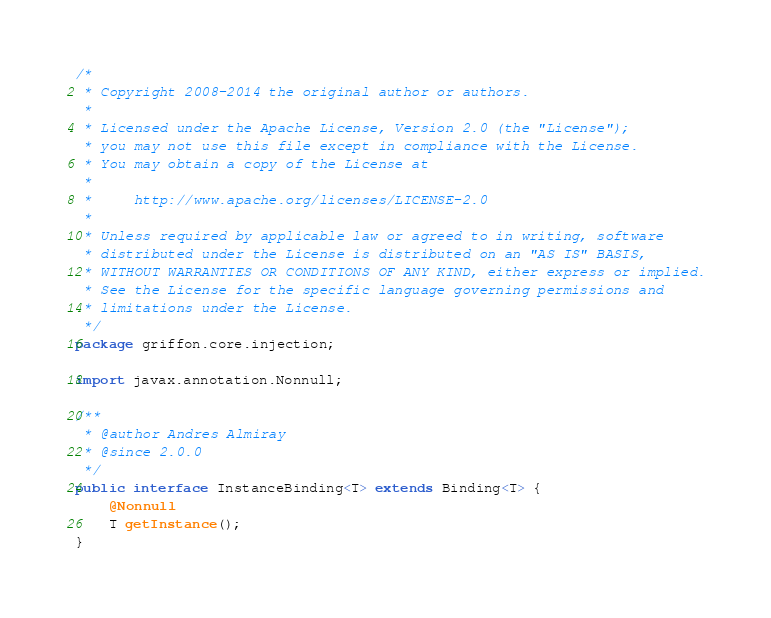Convert code to text. <code><loc_0><loc_0><loc_500><loc_500><_Java_>/*
 * Copyright 2008-2014 the original author or authors.
 *
 * Licensed under the Apache License, Version 2.0 (the "License");
 * you may not use this file except in compliance with the License.
 * You may obtain a copy of the License at
 *
 *     http://www.apache.org/licenses/LICENSE-2.0
 *
 * Unless required by applicable law or agreed to in writing, software
 * distributed under the License is distributed on an "AS IS" BASIS,
 * WITHOUT WARRANTIES OR CONDITIONS OF ANY KIND, either express or implied.
 * See the License for the specific language governing permissions and
 * limitations under the License.
 */
package griffon.core.injection;

import javax.annotation.Nonnull;

/**
 * @author Andres Almiray
 * @since 2.0.0
 */
public interface InstanceBinding<T> extends Binding<T> {
    @Nonnull
    T getInstance();
}
</code> 